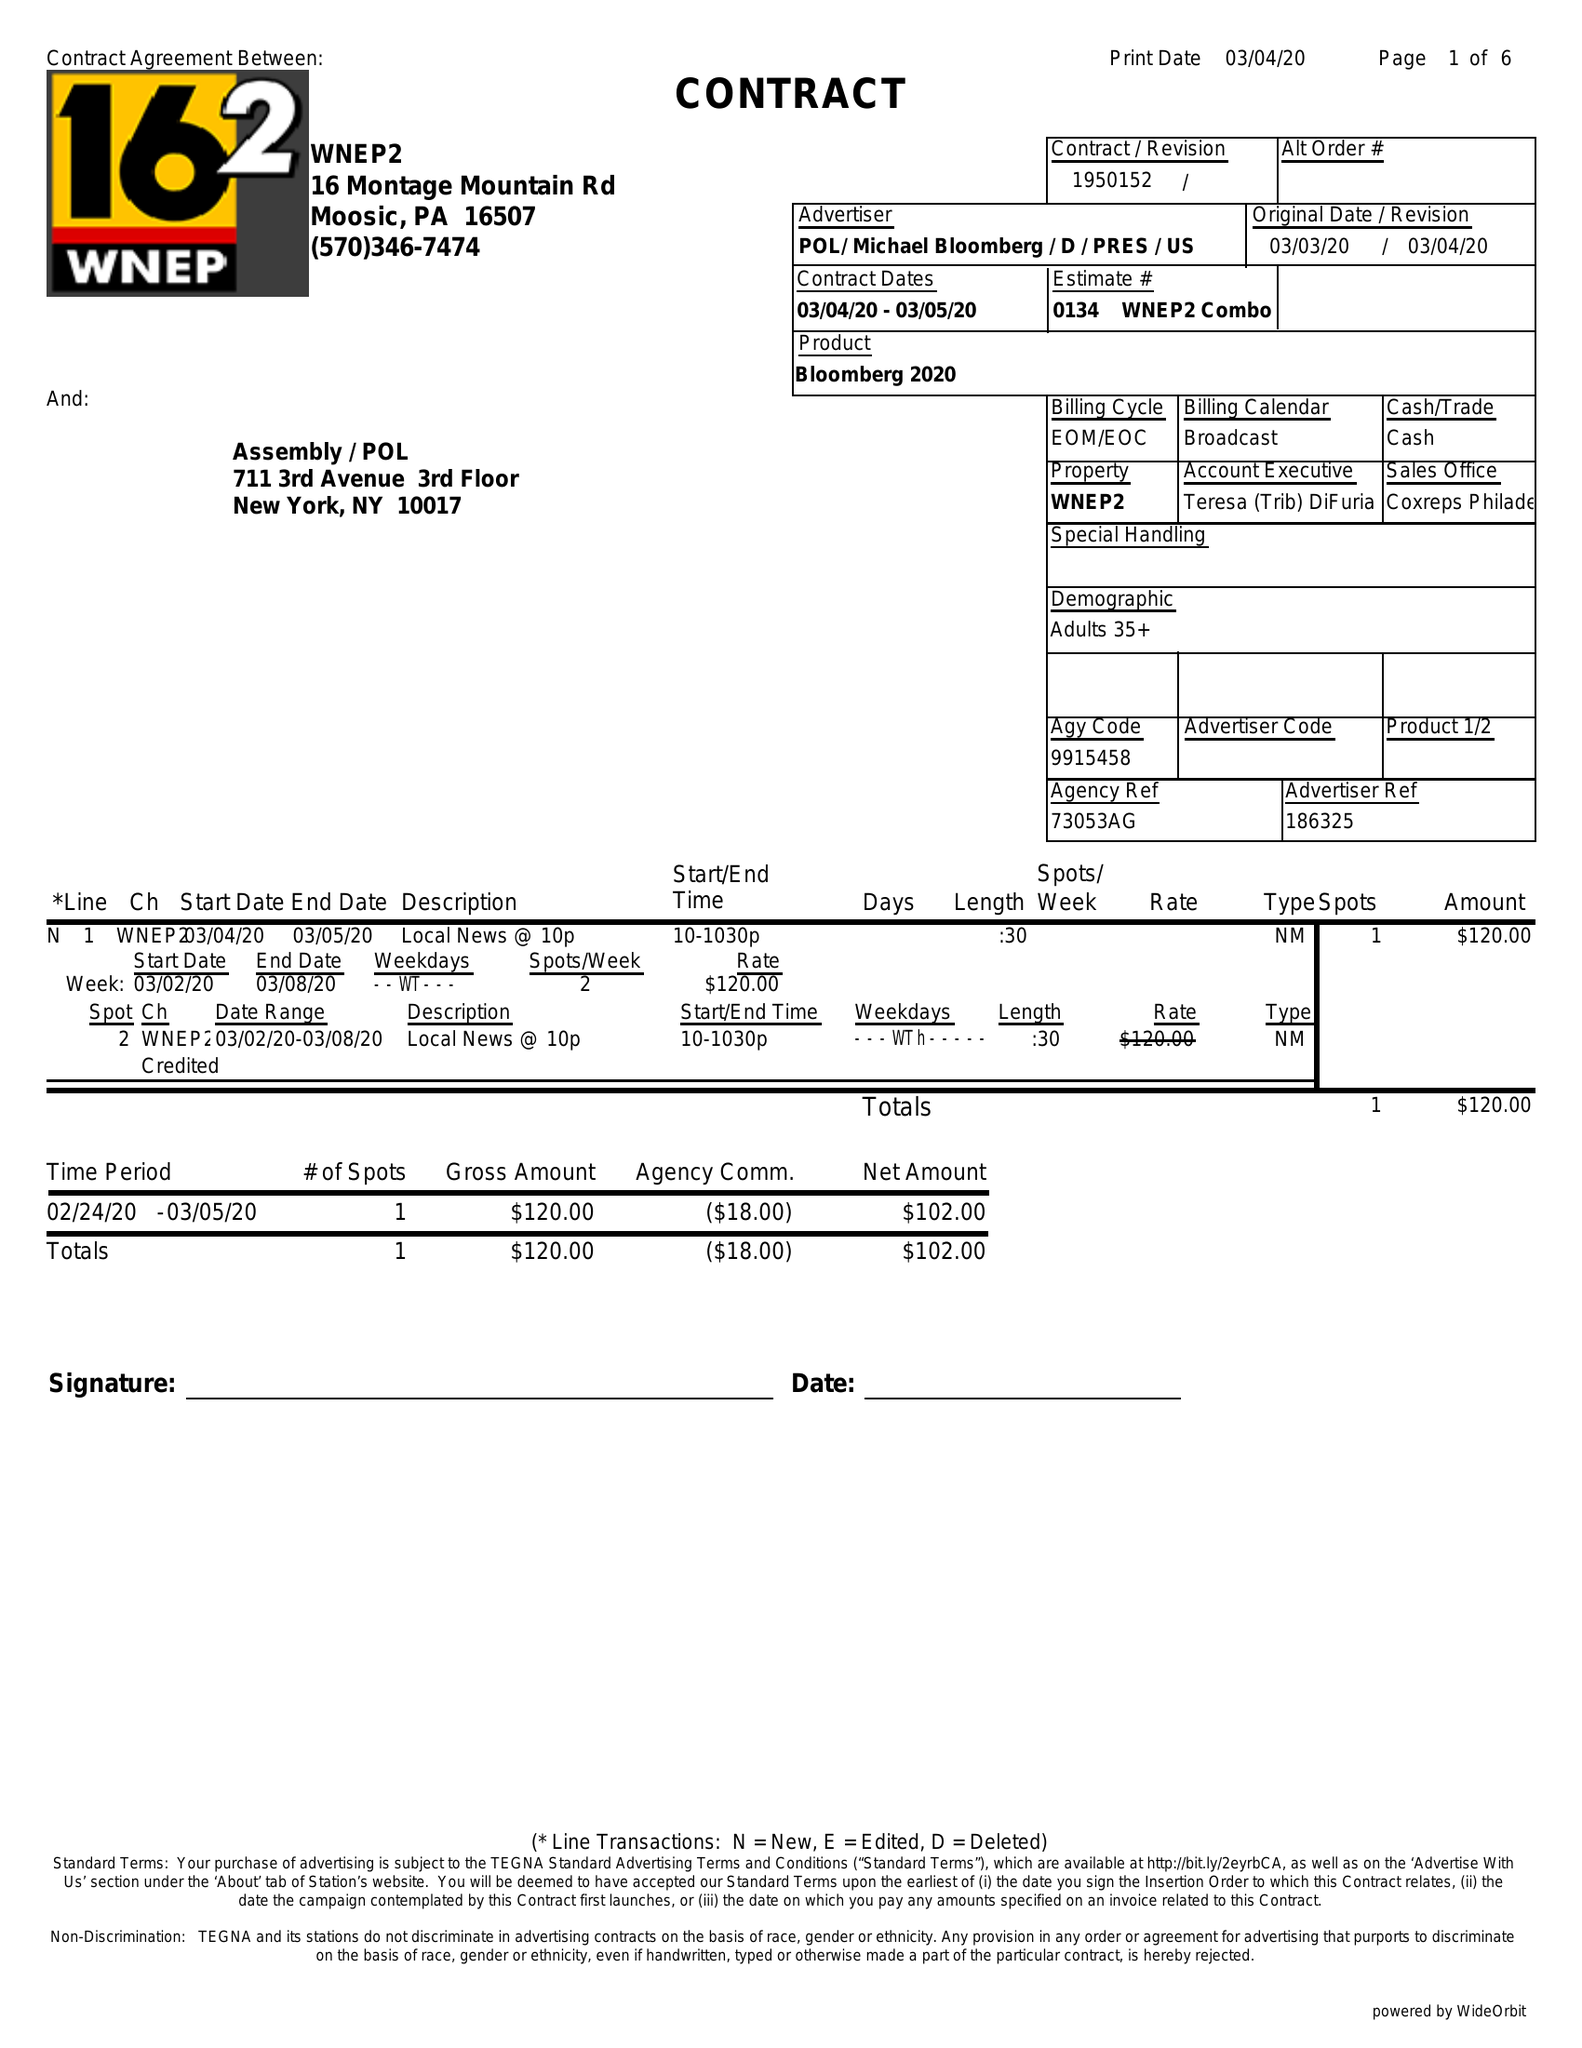What is the value for the flight_from?
Answer the question using a single word or phrase. 03/04/20 